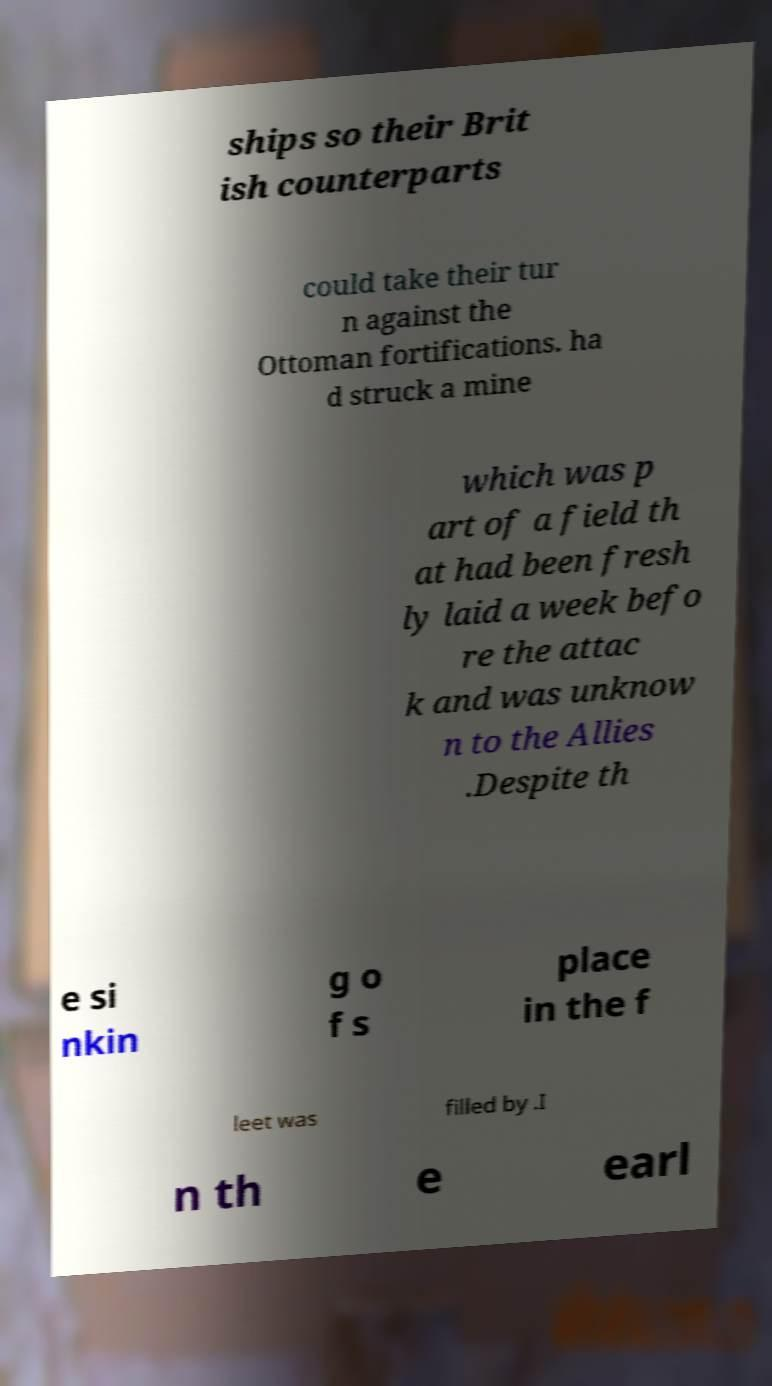Could you extract and type out the text from this image? ships so their Brit ish counterparts could take their tur n against the Ottoman fortifications. ha d struck a mine which was p art of a field th at had been fresh ly laid a week befo re the attac k and was unknow n to the Allies .Despite th e si nkin g o f s place in the f leet was filled by .I n th e earl 